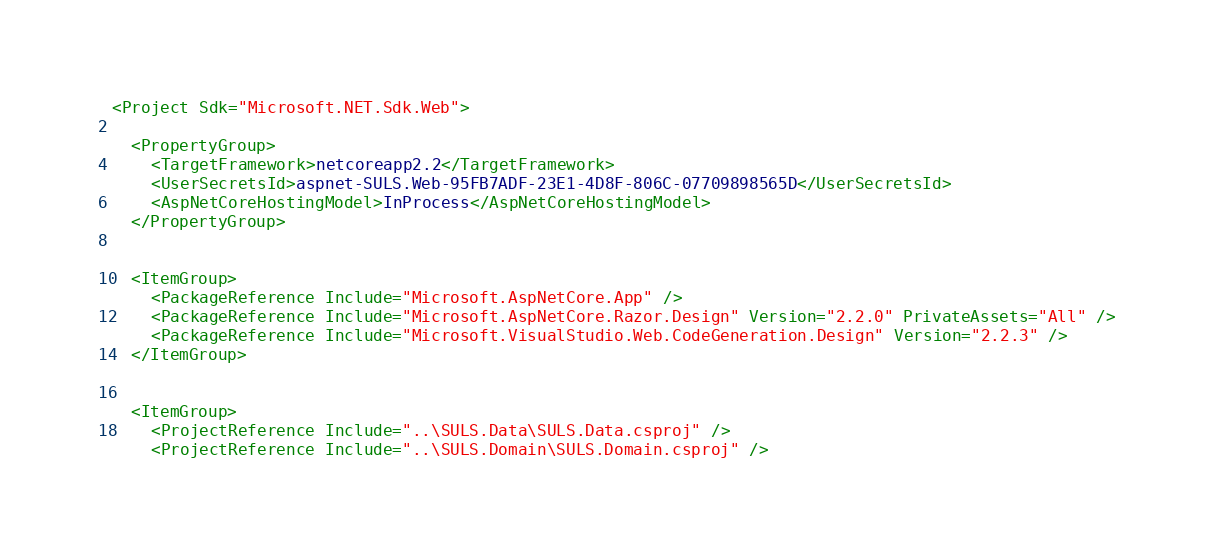<code> <loc_0><loc_0><loc_500><loc_500><_XML_><Project Sdk="Microsoft.NET.Sdk.Web">

  <PropertyGroup>
    <TargetFramework>netcoreapp2.2</TargetFramework>
    <UserSecretsId>aspnet-SULS.Web-95FB7ADF-23E1-4D8F-806C-07709898565D</UserSecretsId>
    <AspNetCoreHostingModel>InProcess</AspNetCoreHostingModel>
  </PropertyGroup>


  <ItemGroup>
    <PackageReference Include="Microsoft.AspNetCore.App" />
    <PackageReference Include="Microsoft.AspNetCore.Razor.Design" Version="2.2.0" PrivateAssets="All" />
    <PackageReference Include="Microsoft.VisualStudio.Web.CodeGeneration.Design" Version="2.2.3" />
  </ItemGroup>


  <ItemGroup>
    <ProjectReference Include="..\SULS.Data\SULS.Data.csproj" />
    <ProjectReference Include="..\SULS.Domain\SULS.Domain.csproj" /></code> 